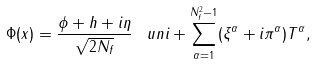<formula> <loc_0><loc_0><loc_500><loc_500>\Phi ( x ) = \frac { \phi + h + i \eta } { \sqrt { 2 N _ { f } } } \, \ u n i + \sum _ { \alpha = 1 } ^ { N _ { f } ^ { 2 } - 1 } ( \xi ^ { \alpha } + i \pi ^ { \alpha } ) T ^ { \alpha } ,</formula> 